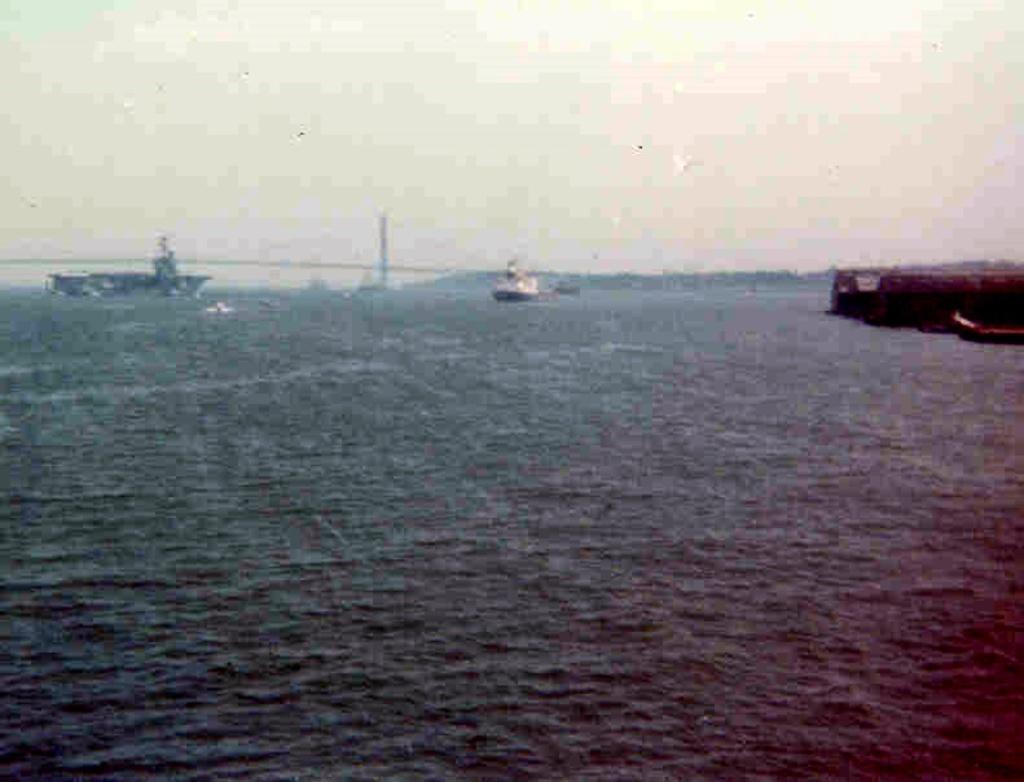Describe this image in one or two sentences. This is an outside view. At the bottom of the image I can see the water. In the background there are two ships on the water. On the right side I can see a wall. On the top of the image I can see the sky. 